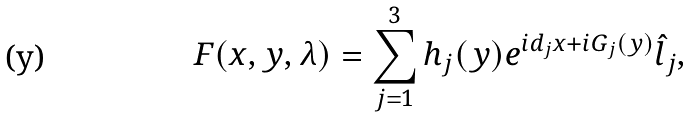Convert formula to latex. <formula><loc_0><loc_0><loc_500><loc_500>F ( x , y , \lambda ) = \sum _ { j = 1 } ^ { 3 } h _ { j } ( y ) e ^ { i d _ { j } x + i G _ { j } ( y ) } \hat { l } _ { j } ,</formula> 